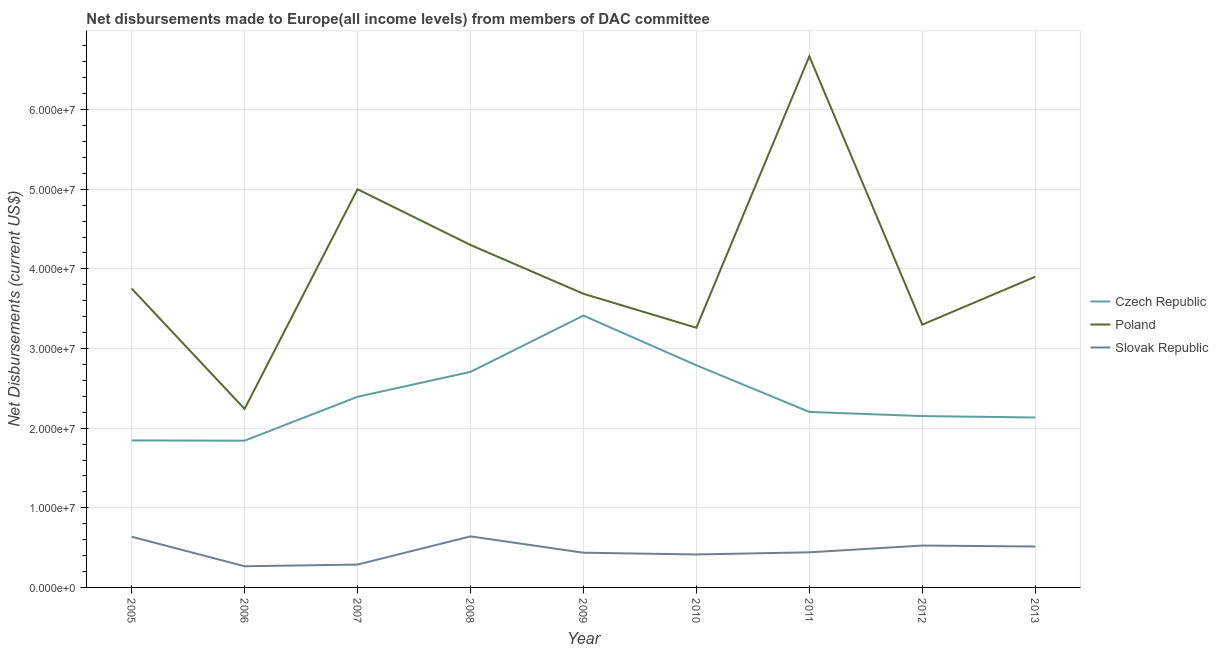How many different coloured lines are there?
Your answer should be compact. 3. What is the net disbursements made by czech republic in 2013?
Your answer should be compact. 2.13e+07. Across all years, what is the maximum net disbursements made by czech republic?
Your answer should be very brief. 3.41e+07. Across all years, what is the minimum net disbursements made by czech republic?
Offer a very short reply. 1.84e+07. In which year was the net disbursements made by poland maximum?
Make the answer very short. 2011. What is the total net disbursements made by poland in the graph?
Make the answer very short. 3.61e+08. What is the difference between the net disbursements made by poland in 2009 and that in 2012?
Provide a short and direct response. 3.88e+06. What is the difference between the net disbursements made by slovak republic in 2013 and the net disbursements made by czech republic in 2007?
Offer a terse response. -1.88e+07. What is the average net disbursements made by slovak republic per year?
Make the answer very short. 4.62e+06. In the year 2009, what is the difference between the net disbursements made by poland and net disbursements made by czech republic?
Ensure brevity in your answer.  2.74e+06. What is the ratio of the net disbursements made by czech republic in 2010 to that in 2012?
Make the answer very short. 1.3. What is the difference between the highest and the lowest net disbursements made by poland?
Offer a very short reply. 4.43e+07. In how many years, is the net disbursements made by czech republic greater than the average net disbursements made by czech republic taken over all years?
Make the answer very short. 4. Is the sum of the net disbursements made by poland in 2006 and 2009 greater than the maximum net disbursements made by czech republic across all years?
Give a very brief answer. Yes. Does the net disbursements made by poland monotonically increase over the years?
Ensure brevity in your answer.  No. Is the net disbursements made by czech republic strictly greater than the net disbursements made by poland over the years?
Provide a succinct answer. No. Is the net disbursements made by slovak republic strictly less than the net disbursements made by poland over the years?
Offer a terse response. Yes. How many lines are there?
Your response must be concise. 3. How many years are there in the graph?
Your answer should be very brief. 9. Does the graph contain any zero values?
Give a very brief answer. No. Where does the legend appear in the graph?
Offer a terse response. Center right. How many legend labels are there?
Your answer should be very brief. 3. How are the legend labels stacked?
Make the answer very short. Vertical. What is the title of the graph?
Your answer should be compact. Net disbursements made to Europe(all income levels) from members of DAC committee. Does "Taxes on income" appear as one of the legend labels in the graph?
Offer a very short reply. No. What is the label or title of the X-axis?
Provide a short and direct response. Year. What is the label or title of the Y-axis?
Keep it short and to the point. Net Disbursements (current US$). What is the Net Disbursements (current US$) of Czech Republic in 2005?
Your answer should be compact. 1.85e+07. What is the Net Disbursements (current US$) in Poland in 2005?
Your response must be concise. 3.75e+07. What is the Net Disbursements (current US$) in Slovak Republic in 2005?
Offer a very short reply. 6.37e+06. What is the Net Disbursements (current US$) in Czech Republic in 2006?
Offer a terse response. 1.84e+07. What is the Net Disbursements (current US$) of Poland in 2006?
Give a very brief answer. 2.24e+07. What is the Net Disbursements (current US$) of Slovak Republic in 2006?
Provide a succinct answer. 2.66e+06. What is the Net Disbursements (current US$) of Czech Republic in 2007?
Make the answer very short. 2.39e+07. What is the Net Disbursements (current US$) of Poland in 2007?
Provide a short and direct response. 5.00e+07. What is the Net Disbursements (current US$) in Slovak Republic in 2007?
Offer a terse response. 2.87e+06. What is the Net Disbursements (current US$) in Czech Republic in 2008?
Your response must be concise. 2.71e+07. What is the Net Disbursements (current US$) of Poland in 2008?
Your answer should be compact. 4.30e+07. What is the Net Disbursements (current US$) of Slovak Republic in 2008?
Offer a very short reply. 6.41e+06. What is the Net Disbursements (current US$) of Czech Republic in 2009?
Provide a succinct answer. 3.41e+07. What is the Net Disbursements (current US$) in Poland in 2009?
Offer a very short reply. 3.69e+07. What is the Net Disbursements (current US$) of Slovak Republic in 2009?
Offer a terse response. 4.36e+06. What is the Net Disbursements (current US$) in Czech Republic in 2010?
Give a very brief answer. 2.79e+07. What is the Net Disbursements (current US$) of Poland in 2010?
Your answer should be compact. 3.26e+07. What is the Net Disbursements (current US$) in Slovak Republic in 2010?
Your response must be concise. 4.14e+06. What is the Net Disbursements (current US$) in Czech Republic in 2011?
Your answer should be compact. 2.20e+07. What is the Net Disbursements (current US$) of Poland in 2011?
Offer a very short reply. 6.67e+07. What is the Net Disbursements (current US$) in Slovak Republic in 2011?
Make the answer very short. 4.41e+06. What is the Net Disbursements (current US$) of Czech Republic in 2012?
Offer a terse response. 2.15e+07. What is the Net Disbursements (current US$) of Poland in 2012?
Provide a short and direct response. 3.30e+07. What is the Net Disbursements (current US$) in Slovak Republic in 2012?
Give a very brief answer. 5.26e+06. What is the Net Disbursements (current US$) of Czech Republic in 2013?
Offer a very short reply. 2.13e+07. What is the Net Disbursements (current US$) in Poland in 2013?
Provide a succinct answer. 3.90e+07. What is the Net Disbursements (current US$) in Slovak Republic in 2013?
Your response must be concise. 5.14e+06. Across all years, what is the maximum Net Disbursements (current US$) of Czech Republic?
Offer a terse response. 3.41e+07. Across all years, what is the maximum Net Disbursements (current US$) of Poland?
Give a very brief answer. 6.67e+07. Across all years, what is the maximum Net Disbursements (current US$) in Slovak Republic?
Keep it short and to the point. 6.41e+06. Across all years, what is the minimum Net Disbursements (current US$) in Czech Republic?
Your response must be concise. 1.84e+07. Across all years, what is the minimum Net Disbursements (current US$) in Poland?
Your answer should be very brief. 2.24e+07. Across all years, what is the minimum Net Disbursements (current US$) of Slovak Republic?
Ensure brevity in your answer.  2.66e+06. What is the total Net Disbursements (current US$) in Czech Republic in the graph?
Your response must be concise. 2.15e+08. What is the total Net Disbursements (current US$) in Poland in the graph?
Ensure brevity in your answer.  3.61e+08. What is the total Net Disbursements (current US$) of Slovak Republic in the graph?
Your response must be concise. 4.16e+07. What is the difference between the Net Disbursements (current US$) of Poland in 2005 and that in 2006?
Provide a short and direct response. 1.51e+07. What is the difference between the Net Disbursements (current US$) of Slovak Republic in 2005 and that in 2006?
Ensure brevity in your answer.  3.71e+06. What is the difference between the Net Disbursements (current US$) in Czech Republic in 2005 and that in 2007?
Keep it short and to the point. -5.48e+06. What is the difference between the Net Disbursements (current US$) of Poland in 2005 and that in 2007?
Keep it short and to the point. -1.25e+07. What is the difference between the Net Disbursements (current US$) of Slovak Republic in 2005 and that in 2007?
Your answer should be compact. 3.50e+06. What is the difference between the Net Disbursements (current US$) of Czech Republic in 2005 and that in 2008?
Ensure brevity in your answer.  -8.61e+06. What is the difference between the Net Disbursements (current US$) of Poland in 2005 and that in 2008?
Your answer should be compact. -5.47e+06. What is the difference between the Net Disbursements (current US$) of Czech Republic in 2005 and that in 2009?
Provide a short and direct response. -1.57e+07. What is the difference between the Net Disbursements (current US$) in Slovak Republic in 2005 and that in 2009?
Provide a short and direct response. 2.01e+06. What is the difference between the Net Disbursements (current US$) in Czech Republic in 2005 and that in 2010?
Provide a short and direct response. -9.44e+06. What is the difference between the Net Disbursements (current US$) of Poland in 2005 and that in 2010?
Offer a terse response. 4.93e+06. What is the difference between the Net Disbursements (current US$) of Slovak Republic in 2005 and that in 2010?
Your answer should be compact. 2.23e+06. What is the difference between the Net Disbursements (current US$) in Czech Republic in 2005 and that in 2011?
Ensure brevity in your answer.  -3.58e+06. What is the difference between the Net Disbursements (current US$) in Poland in 2005 and that in 2011?
Keep it short and to the point. -2.92e+07. What is the difference between the Net Disbursements (current US$) in Slovak Republic in 2005 and that in 2011?
Ensure brevity in your answer.  1.96e+06. What is the difference between the Net Disbursements (current US$) in Czech Republic in 2005 and that in 2012?
Offer a terse response. -3.06e+06. What is the difference between the Net Disbursements (current US$) in Poland in 2005 and that in 2012?
Make the answer very short. 4.54e+06. What is the difference between the Net Disbursements (current US$) in Slovak Republic in 2005 and that in 2012?
Provide a short and direct response. 1.11e+06. What is the difference between the Net Disbursements (current US$) in Czech Republic in 2005 and that in 2013?
Make the answer very short. -2.88e+06. What is the difference between the Net Disbursements (current US$) of Poland in 2005 and that in 2013?
Provide a short and direct response. -1.48e+06. What is the difference between the Net Disbursements (current US$) in Slovak Republic in 2005 and that in 2013?
Provide a succinct answer. 1.23e+06. What is the difference between the Net Disbursements (current US$) of Czech Republic in 2006 and that in 2007?
Your answer should be very brief. -5.51e+06. What is the difference between the Net Disbursements (current US$) in Poland in 2006 and that in 2007?
Your answer should be compact. -2.76e+07. What is the difference between the Net Disbursements (current US$) in Czech Republic in 2006 and that in 2008?
Provide a succinct answer. -8.64e+06. What is the difference between the Net Disbursements (current US$) of Poland in 2006 and that in 2008?
Provide a succinct answer. -2.06e+07. What is the difference between the Net Disbursements (current US$) in Slovak Republic in 2006 and that in 2008?
Your response must be concise. -3.75e+06. What is the difference between the Net Disbursements (current US$) of Czech Republic in 2006 and that in 2009?
Your response must be concise. -1.57e+07. What is the difference between the Net Disbursements (current US$) in Poland in 2006 and that in 2009?
Provide a succinct answer. -1.45e+07. What is the difference between the Net Disbursements (current US$) in Slovak Republic in 2006 and that in 2009?
Give a very brief answer. -1.70e+06. What is the difference between the Net Disbursements (current US$) of Czech Republic in 2006 and that in 2010?
Give a very brief answer. -9.47e+06. What is the difference between the Net Disbursements (current US$) in Poland in 2006 and that in 2010?
Keep it short and to the point. -1.02e+07. What is the difference between the Net Disbursements (current US$) of Slovak Republic in 2006 and that in 2010?
Offer a terse response. -1.48e+06. What is the difference between the Net Disbursements (current US$) in Czech Republic in 2006 and that in 2011?
Give a very brief answer. -3.61e+06. What is the difference between the Net Disbursements (current US$) of Poland in 2006 and that in 2011?
Offer a very short reply. -4.43e+07. What is the difference between the Net Disbursements (current US$) of Slovak Republic in 2006 and that in 2011?
Offer a very short reply. -1.75e+06. What is the difference between the Net Disbursements (current US$) in Czech Republic in 2006 and that in 2012?
Offer a very short reply. -3.09e+06. What is the difference between the Net Disbursements (current US$) in Poland in 2006 and that in 2012?
Keep it short and to the point. -1.06e+07. What is the difference between the Net Disbursements (current US$) of Slovak Republic in 2006 and that in 2012?
Ensure brevity in your answer.  -2.60e+06. What is the difference between the Net Disbursements (current US$) in Czech Republic in 2006 and that in 2013?
Keep it short and to the point. -2.91e+06. What is the difference between the Net Disbursements (current US$) of Poland in 2006 and that in 2013?
Your answer should be compact. -1.66e+07. What is the difference between the Net Disbursements (current US$) in Slovak Republic in 2006 and that in 2013?
Keep it short and to the point. -2.48e+06. What is the difference between the Net Disbursements (current US$) in Czech Republic in 2007 and that in 2008?
Your answer should be compact. -3.13e+06. What is the difference between the Net Disbursements (current US$) of Poland in 2007 and that in 2008?
Your answer should be very brief. 7.00e+06. What is the difference between the Net Disbursements (current US$) in Slovak Republic in 2007 and that in 2008?
Make the answer very short. -3.54e+06. What is the difference between the Net Disbursements (current US$) of Czech Republic in 2007 and that in 2009?
Provide a short and direct response. -1.02e+07. What is the difference between the Net Disbursements (current US$) of Poland in 2007 and that in 2009?
Offer a terse response. 1.31e+07. What is the difference between the Net Disbursements (current US$) in Slovak Republic in 2007 and that in 2009?
Provide a succinct answer. -1.49e+06. What is the difference between the Net Disbursements (current US$) in Czech Republic in 2007 and that in 2010?
Offer a terse response. -3.96e+06. What is the difference between the Net Disbursements (current US$) in Poland in 2007 and that in 2010?
Ensure brevity in your answer.  1.74e+07. What is the difference between the Net Disbursements (current US$) in Slovak Republic in 2007 and that in 2010?
Provide a succinct answer. -1.27e+06. What is the difference between the Net Disbursements (current US$) in Czech Republic in 2007 and that in 2011?
Your answer should be very brief. 1.90e+06. What is the difference between the Net Disbursements (current US$) in Poland in 2007 and that in 2011?
Make the answer very short. -1.67e+07. What is the difference between the Net Disbursements (current US$) in Slovak Republic in 2007 and that in 2011?
Give a very brief answer. -1.54e+06. What is the difference between the Net Disbursements (current US$) of Czech Republic in 2007 and that in 2012?
Provide a succinct answer. 2.42e+06. What is the difference between the Net Disbursements (current US$) of Poland in 2007 and that in 2012?
Your response must be concise. 1.70e+07. What is the difference between the Net Disbursements (current US$) in Slovak Republic in 2007 and that in 2012?
Give a very brief answer. -2.39e+06. What is the difference between the Net Disbursements (current US$) of Czech Republic in 2007 and that in 2013?
Give a very brief answer. 2.60e+06. What is the difference between the Net Disbursements (current US$) in Poland in 2007 and that in 2013?
Provide a short and direct response. 1.10e+07. What is the difference between the Net Disbursements (current US$) of Slovak Republic in 2007 and that in 2013?
Provide a succinct answer. -2.27e+06. What is the difference between the Net Disbursements (current US$) of Czech Republic in 2008 and that in 2009?
Provide a short and direct response. -7.07e+06. What is the difference between the Net Disbursements (current US$) in Poland in 2008 and that in 2009?
Keep it short and to the point. 6.13e+06. What is the difference between the Net Disbursements (current US$) in Slovak Republic in 2008 and that in 2009?
Your answer should be compact. 2.05e+06. What is the difference between the Net Disbursements (current US$) of Czech Republic in 2008 and that in 2010?
Make the answer very short. -8.30e+05. What is the difference between the Net Disbursements (current US$) of Poland in 2008 and that in 2010?
Offer a terse response. 1.04e+07. What is the difference between the Net Disbursements (current US$) of Slovak Republic in 2008 and that in 2010?
Keep it short and to the point. 2.27e+06. What is the difference between the Net Disbursements (current US$) of Czech Republic in 2008 and that in 2011?
Offer a very short reply. 5.03e+06. What is the difference between the Net Disbursements (current US$) of Poland in 2008 and that in 2011?
Offer a terse response. -2.37e+07. What is the difference between the Net Disbursements (current US$) of Czech Republic in 2008 and that in 2012?
Provide a short and direct response. 5.55e+06. What is the difference between the Net Disbursements (current US$) in Poland in 2008 and that in 2012?
Your answer should be compact. 1.00e+07. What is the difference between the Net Disbursements (current US$) of Slovak Republic in 2008 and that in 2012?
Offer a very short reply. 1.15e+06. What is the difference between the Net Disbursements (current US$) of Czech Republic in 2008 and that in 2013?
Provide a succinct answer. 5.73e+06. What is the difference between the Net Disbursements (current US$) of Poland in 2008 and that in 2013?
Keep it short and to the point. 3.99e+06. What is the difference between the Net Disbursements (current US$) of Slovak Republic in 2008 and that in 2013?
Your answer should be very brief. 1.27e+06. What is the difference between the Net Disbursements (current US$) of Czech Republic in 2009 and that in 2010?
Give a very brief answer. 6.24e+06. What is the difference between the Net Disbursements (current US$) of Poland in 2009 and that in 2010?
Your response must be concise. 4.27e+06. What is the difference between the Net Disbursements (current US$) of Czech Republic in 2009 and that in 2011?
Offer a very short reply. 1.21e+07. What is the difference between the Net Disbursements (current US$) in Poland in 2009 and that in 2011?
Give a very brief answer. -2.98e+07. What is the difference between the Net Disbursements (current US$) in Slovak Republic in 2009 and that in 2011?
Ensure brevity in your answer.  -5.00e+04. What is the difference between the Net Disbursements (current US$) in Czech Republic in 2009 and that in 2012?
Your answer should be very brief. 1.26e+07. What is the difference between the Net Disbursements (current US$) of Poland in 2009 and that in 2012?
Offer a terse response. 3.88e+06. What is the difference between the Net Disbursements (current US$) in Slovak Republic in 2009 and that in 2012?
Offer a very short reply. -9.00e+05. What is the difference between the Net Disbursements (current US$) of Czech Republic in 2009 and that in 2013?
Provide a short and direct response. 1.28e+07. What is the difference between the Net Disbursements (current US$) of Poland in 2009 and that in 2013?
Give a very brief answer. -2.14e+06. What is the difference between the Net Disbursements (current US$) in Slovak Republic in 2009 and that in 2013?
Provide a short and direct response. -7.80e+05. What is the difference between the Net Disbursements (current US$) in Czech Republic in 2010 and that in 2011?
Offer a very short reply. 5.86e+06. What is the difference between the Net Disbursements (current US$) in Poland in 2010 and that in 2011?
Make the answer very short. -3.41e+07. What is the difference between the Net Disbursements (current US$) of Czech Republic in 2010 and that in 2012?
Provide a succinct answer. 6.38e+06. What is the difference between the Net Disbursements (current US$) in Poland in 2010 and that in 2012?
Give a very brief answer. -3.90e+05. What is the difference between the Net Disbursements (current US$) in Slovak Republic in 2010 and that in 2012?
Your response must be concise. -1.12e+06. What is the difference between the Net Disbursements (current US$) of Czech Republic in 2010 and that in 2013?
Offer a very short reply. 6.56e+06. What is the difference between the Net Disbursements (current US$) in Poland in 2010 and that in 2013?
Your response must be concise. -6.41e+06. What is the difference between the Net Disbursements (current US$) in Czech Republic in 2011 and that in 2012?
Ensure brevity in your answer.  5.20e+05. What is the difference between the Net Disbursements (current US$) of Poland in 2011 and that in 2012?
Make the answer very short. 3.37e+07. What is the difference between the Net Disbursements (current US$) of Slovak Republic in 2011 and that in 2012?
Offer a very short reply. -8.50e+05. What is the difference between the Net Disbursements (current US$) in Poland in 2011 and that in 2013?
Offer a terse response. 2.77e+07. What is the difference between the Net Disbursements (current US$) of Slovak Republic in 2011 and that in 2013?
Offer a terse response. -7.30e+05. What is the difference between the Net Disbursements (current US$) of Poland in 2012 and that in 2013?
Give a very brief answer. -6.02e+06. What is the difference between the Net Disbursements (current US$) in Slovak Republic in 2012 and that in 2013?
Offer a very short reply. 1.20e+05. What is the difference between the Net Disbursements (current US$) in Czech Republic in 2005 and the Net Disbursements (current US$) in Poland in 2006?
Make the answer very short. -3.96e+06. What is the difference between the Net Disbursements (current US$) in Czech Republic in 2005 and the Net Disbursements (current US$) in Slovak Republic in 2006?
Your answer should be very brief. 1.58e+07. What is the difference between the Net Disbursements (current US$) in Poland in 2005 and the Net Disbursements (current US$) in Slovak Republic in 2006?
Make the answer very short. 3.49e+07. What is the difference between the Net Disbursements (current US$) in Czech Republic in 2005 and the Net Disbursements (current US$) in Poland in 2007?
Provide a short and direct response. -3.16e+07. What is the difference between the Net Disbursements (current US$) of Czech Republic in 2005 and the Net Disbursements (current US$) of Slovak Republic in 2007?
Ensure brevity in your answer.  1.56e+07. What is the difference between the Net Disbursements (current US$) in Poland in 2005 and the Net Disbursements (current US$) in Slovak Republic in 2007?
Offer a terse response. 3.47e+07. What is the difference between the Net Disbursements (current US$) of Czech Republic in 2005 and the Net Disbursements (current US$) of Poland in 2008?
Your answer should be compact. -2.46e+07. What is the difference between the Net Disbursements (current US$) in Czech Republic in 2005 and the Net Disbursements (current US$) in Slovak Republic in 2008?
Your answer should be compact. 1.20e+07. What is the difference between the Net Disbursements (current US$) of Poland in 2005 and the Net Disbursements (current US$) of Slovak Republic in 2008?
Give a very brief answer. 3.11e+07. What is the difference between the Net Disbursements (current US$) of Czech Republic in 2005 and the Net Disbursements (current US$) of Poland in 2009?
Give a very brief answer. -1.84e+07. What is the difference between the Net Disbursements (current US$) of Czech Republic in 2005 and the Net Disbursements (current US$) of Slovak Republic in 2009?
Your answer should be compact. 1.41e+07. What is the difference between the Net Disbursements (current US$) in Poland in 2005 and the Net Disbursements (current US$) in Slovak Republic in 2009?
Provide a succinct answer. 3.32e+07. What is the difference between the Net Disbursements (current US$) in Czech Republic in 2005 and the Net Disbursements (current US$) in Poland in 2010?
Provide a short and direct response. -1.42e+07. What is the difference between the Net Disbursements (current US$) of Czech Republic in 2005 and the Net Disbursements (current US$) of Slovak Republic in 2010?
Your response must be concise. 1.43e+07. What is the difference between the Net Disbursements (current US$) of Poland in 2005 and the Net Disbursements (current US$) of Slovak Republic in 2010?
Ensure brevity in your answer.  3.34e+07. What is the difference between the Net Disbursements (current US$) of Czech Republic in 2005 and the Net Disbursements (current US$) of Poland in 2011?
Keep it short and to the point. -4.82e+07. What is the difference between the Net Disbursements (current US$) of Czech Republic in 2005 and the Net Disbursements (current US$) of Slovak Republic in 2011?
Offer a terse response. 1.40e+07. What is the difference between the Net Disbursements (current US$) in Poland in 2005 and the Net Disbursements (current US$) in Slovak Republic in 2011?
Provide a short and direct response. 3.31e+07. What is the difference between the Net Disbursements (current US$) in Czech Republic in 2005 and the Net Disbursements (current US$) in Poland in 2012?
Ensure brevity in your answer.  -1.45e+07. What is the difference between the Net Disbursements (current US$) of Czech Republic in 2005 and the Net Disbursements (current US$) of Slovak Republic in 2012?
Provide a succinct answer. 1.32e+07. What is the difference between the Net Disbursements (current US$) of Poland in 2005 and the Net Disbursements (current US$) of Slovak Republic in 2012?
Ensure brevity in your answer.  3.23e+07. What is the difference between the Net Disbursements (current US$) in Czech Republic in 2005 and the Net Disbursements (current US$) in Poland in 2013?
Keep it short and to the point. -2.06e+07. What is the difference between the Net Disbursements (current US$) in Czech Republic in 2005 and the Net Disbursements (current US$) in Slovak Republic in 2013?
Provide a succinct answer. 1.33e+07. What is the difference between the Net Disbursements (current US$) of Poland in 2005 and the Net Disbursements (current US$) of Slovak Republic in 2013?
Offer a terse response. 3.24e+07. What is the difference between the Net Disbursements (current US$) of Czech Republic in 2006 and the Net Disbursements (current US$) of Poland in 2007?
Provide a short and direct response. -3.16e+07. What is the difference between the Net Disbursements (current US$) of Czech Republic in 2006 and the Net Disbursements (current US$) of Slovak Republic in 2007?
Keep it short and to the point. 1.56e+07. What is the difference between the Net Disbursements (current US$) in Poland in 2006 and the Net Disbursements (current US$) in Slovak Republic in 2007?
Your response must be concise. 1.96e+07. What is the difference between the Net Disbursements (current US$) of Czech Republic in 2006 and the Net Disbursements (current US$) of Poland in 2008?
Keep it short and to the point. -2.46e+07. What is the difference between the Net Disbursements (current US$) in Czech Republic in 2006 and the Net Disbursements (current US$) in Slovak Republic in 2008?
Ensure brevity in your answer.  1.20e+07. What is the difference between the Net Disbursements (current US$) in Poland in 2006 and the Net Disbursements (current US$) in Slovak Republic in 2008?
Make the answer very short. 1.60e+07. What is the difference between the Net Disbursements (current US$) in Czech Republic in 2006 and the Net Disbursements (current US$) in Poland in 2009?
Offer a very short reply. -1.84e+07. What is the difference between the Net Disbursements (current US$) of Czech Republic in 2006 and the Net Disbursements (current US$) of Slovak Republic in 2009?
Provide a short and direct response. 1.41e+07. What is the difference between the Net Disbursements (current US$) in Poland in 2006 and the Net Disbursements (current US$) in Slovak Republic in 2009?
Give a very brief answer. 1.81e+07. What is the difference between the Net Disbursements (current US$) in Czech Republic in 2006 and the Net Disbursements (current US$) in Poland in 2010?
Ensure brevity in your answer.  -1.42e+07. What is the difference between the Net Disbursements (current US$) of Czech Republic in 2006 and the Net Disbursements (current US$) of Slovak Republic in 2010?
Offer a terse response. 1.43e+07. What is the difference between the Net Disbursements (current US$) of Poland in 2006 and the Net Disbursements (current US$) of Slovak Republic in 2010?
Provide a short and direct response. 1.83e+07. What is the difference between the Net Disbursements (current US$) of Czech Republic in 2006 and the Net Disbursements (current US$) of Poland in 2011?
Make the answer very short. -4.83e+07. What is the difference between the Net Disbursements (current US$) of Czech Republic in 2006 and the Net Disbursements (current US$) of Slovak Republic in 2011?
Offer a very short reply. 1.40e+07. What is the difference between the Net Disbursements (current US$) in Poland in 2006 and the Net Disbursements (current US$) in Slovak Republic in 2011?
Ensure brevity in your answer.  1.80e+07. What is the difference between the Net Disbursements (current US$) of Czech Republic in 2006 and the Net Disbursements (current US$) of Poland in 2012?
Your answer should be compact. -1.46e+07. What is the difference between the Net Disbursements (current US$) of Czech Republic in 2006 and the Net Disbursements (current US$) of Slovak Republic in 2012?
Ensure brevity in your answer.  1.32e+07. What is the difference between the Net Disbursements (current US$) of Poland in 2006 and the Net Disbursements (current US$) of Slovak Republic in 2012?
Make the answer very short. 1.72e+07. What is the difference between the Net Disbursements (current US$) in Czech Republic in 2006 and the Net Disbursements (current US$) in Poland in 2013?
Give a very brief answer. -2.06e+07. What is the difference between the Net Disbursements (current US$) in Czech Republic in 2006 and the Net Disbursements (current US$) in Slovak Republic in 2013?
Ensure brevity in your answer.  1.33e+07. What is the difference between the Net Disbursements (current US$) of Poland in 2006 and the Net Disbursements (current US$) of Slovak Republic in 2013?
Provide a succinct answer. 1.73e+07. What is the difference between the Net Disbursements (current US$) of Czech Republic in 2007 and the Net Disbursements (current US$) of Poland in 2008?
Provide a short and direct response. -1.91e+07. What is the difference between the Net Disbursements (current US$) of Czech Republic in 2007 and the Net Disbursements (current US$) of Slovak Republic in 2008?
Keep it short and to the point. 1.75e+07. What is the difference between the Net Disbursements (current US$) of Poland in 2007 and the Net Disbursements (current US$) of Slovak Republic in 2008?
Your response must be concise. 4.36e+07. What is the difference between the Net Disbursements (current US$) in Czech Republic in 2007 and the Net Disbursements (current US$) in Poland in 2009?
Give a very brief answer. -1.29e+07. What is the difference between the Net Disbursements (current US$) of Czech Republic in 2007 and the Net Disbursements (current US$) of Slovak Republic in 2009?
Provide a short and direct response. 1.96e+07. What is the difference between the Net Disbursements (current US$) of Poland in 2007 and the Net Disbursements (current US$) of Slovak Republic in 2009?
Provide a succinct answer. 4.56e+07. What is the difference between the Net Disbursements (current US$) of Czech Republic in 2007 and the Net Disbursements (current US$) of Poland in 2010?
Provide a succinct answer. -8.67e+06. What is the difference between the Net Disbursements (current US$) in Czech Republic in 2007 and the Net Disbursements (current US$) in Slovak Republic in 2010?
Provide a succinct answer. 1.98e+07. What is the difference between the Net Disbursements (current US$) of Poland in 2007 and the Net Disbursements (current US$) of Slovak Republic in 2010?
Your answer should be compact. 4.59e+07. What is the difference between the Net Disbursements (current US$) of Czech Republic in 2007 and the Net Disbursements (current US$) of Poland in 2011?
Make the answer very short. -4.28e+07. What is the difference between the Net Disbursements (current US$) of Czech Republic in 2007 and the Net Disbursements (current US$) of Slovak Republic in 2011?
Provide a short and direct response. 1.95e+07. What is the difference between the Net Disbursements (current US$) in Poland in 2007 and the Net Disbursements (current US$) in Slovak Republic in 2011?
Offer a terse response. 4.56e+07. What is the difference between the Net Disbursements (current US$) of Czech Republic in 2007 and the Net Disbursements (current US$) of Poland in 2012?
Offer a very short reply. -9.06e+06. What is the difference between the Net Disbursements (current US$) in Czech Republic in 2007 and the Net Disbursements (current US$) in Slovak Republic in 2012?
Offer a very short reply. 1.87e+07. What is the difference between the Net Disbursements (current US$) in Poland in 2007 and the Net Disbursements (current US$) in Slovak Republic in 2012?
Offer a terse response. 4.48e+07. What is the difference between the Net Disbursements (current US$) of Czech Republic in 2007 and the Net Disbursements (current US$) of Poland in 2013?
Ensure brevity in your answer.  -1.51e+07. What is the difference between the Net Disbursements (current US$) in Czech Republic in 2007 and the Net Disbursements (current US$) in Slovak Republic in 2013?
Give a very brief answer. 1.88e+07. What is the difference between the Net Disbursements (current US$) of Poland in 2007 and the Net Disbursements (current US$) of Slovak Republic in 2013?
Provide a succinct answer. 4.49e+07. What is the difference between the Net Disbursements (current US$) in Czech Republic in 2008 and the Net Disbursements (current US$) in Poland in 2009?
Offer a terse response. -9.81e+06. What is the difference between the Net Disbursements (current US$) of Czech Republic in 2008 and the Net Disbursements (current US$) of Slovak Republic in 2009?
Make the answer very short. 2.27e+07. What is the difference between the Net Disbursements (current US$) in Poland in 2008 and the Net Disbursements (current US$) in Slovak Republic in 2009?
Your response must be concise. 3.86e+07. What is the difference between the Net Disbursements (current US$) in Czech Republic in 2008 and the Net Disbursements (current US$) in Poland in 2010?
Offer a terse response. -5.54e+06. What is the difference between the Net Disbursements (current US$) of Czech Republic in 2008 and the Net Disbursements (current US$) of Slovak Republic in 2010?
Give a very brief answer. 2.29e+07. What is the difference between the Net Disbursements (current US$) in Poland in 2008 and the Net Disbursements (current US$) in Slovak Republic in 2010?
Give a very brief answer. 3.89e+07. What is the difference between the Net Disbursements (current US$) of Czech Republic in 2008 and the Net Disbursements (current US$) of Poland in 2011?
Offer a very short reply. -3.96e+07. What is the difference between the Net Disbursements (current US$) of Czech Republic in 2008 and the Net Disbursements (current US$) of Slovak Republic in 2011?
Your answer should be very brief. 2.27e+07. What is the difference between the Net Disbursements (current US$) in Poland in 2008 and the Net Disbursements (current US$) in Slovak Republic in 2011?
Keep it short and to the point. 3.86e+07. What is the difference between the Net Disbursements (current US$) in Czech Republic in 2008 and the Net Disbursements (current US$) in Poland in 2012?
Keep it short and to the point. -5.93e+06. What is the difference between the Net Disbursements (current US$) of Czech Republic in 2008 and the Net Disbursements (current US$) of Slovak Republic in 2012?
Offer a terse response. 2.18e+07. What is the difference between the Net Disbursements (current US$) of Poland in 2008 and the Net Disbursements (current US$) of Slovak Republic in 2012?
Provide a succinct answer. 3.78e+07. What is the difference between the Net Disbursements (current US$) in Czech Republic in 2008 and the Net Disbursements (current US$) in Poland in 2013?
Your answer should be very brief. -1.20e+07. What is the difference between the Net Disbursements (current US$) of Czech Republic in 2008 and the Net Disbursements (current US$) of Slovak Republic in 2013?
Your answer should be compact. 2.19e+07. What is the difference between the Net Disbursements (current US$) of Poland in 2008 and the Net Disbursements (current US$) of Slovak Republic in 2013?
Offer a terse response. 3.79e+07. What is the difference between the Net Disbursements (current US$) in Czech Republic in 2009 and the Net Disbursements (current US$) in Poland in 2010?
Provide a succinct answer. 1.53e+06. What is the difference between the Net Disbursements (current US$) of Czech Republic in 2009 and the Net Disbursements (current US$) of Slovak Republic in 2010?
Provide a succinct answer. 3.00e+07. What is the difference between the Net Disbursements (current US$) of Poland in 2009 and the Net Disbursements (current US$) of Slovak Republic in 2010?
Your answer should be very brief. 3.27e+07. What is the difference between the Net Disbursements (current US$) of Czech Republic in 2009 and the Net Disbursements (current US$) of Poland in 2011?
Provide a succinct answer. -3.26e+07. What is the difference between the Net Disbursements (current US$) of Czech Republic in 2009 and the Net Disbursements (current US$) of Slovak Republic in 2011?
Offer a very short reply. 2.97e+07. What is the difference between the Net Disbursements (current US$) in Poland in 2009 and the Net Disbursements (current US$) in Slovak Republic in 2011?
Give a very brief answer. 3.25e+07. What is the difference between the Net Disbursements (current US$) of Czech Republic in 2009 and the Net Disbursements (current US$) of Poland in 2012?
Your response must be concise. 1.14e+06. What is the difference between the Net Disbursements (current US$) of Czech Republic in 2009 and the Net Disbursements (current US$) of Slovak Republic in 2012?
Provide a short and direct response. 2.89e+07. What is the difference between the Net Disbursements (current US$) in Poland in 2009 and the Net Disbursements (current US$) in Slovak Republic in 2012?
Provide a succinct answer. 3.16e+07. What is the difference between the Net Disbursements (current US$) of Czech Republic in 2009 and the Net Disbursements (current US$) of Poland in 2013?
Make the answer very short. -4.88e+06. What is the difference between the Net Disbursements (current US$) of Czech Republic in 2009 and the Net Disbursements (current US$) of Slovak Republic in 2013?
Your answer should be compact. 2.90e+07. What is the difference between the Net Disbursements (current US$) of Poland in 2009 and the Net Disbursements (current US$) of Slovak Republic in 2013?
Keep it short and to the point. 3.17e+07. What is the difference between the Net Disbursements (current US$) in Czech Republic in 2010 and the Net Disbursements (current US$) in Poland in 2011?
Your response must be concise. -3.88e+07. What is the difference between the Net Disbursements (current US$) in Czech Republic in 2010 and the Net Disbursements (current US$) in Slovak Republic in 2011?
Your answer should be very brief. 2.35e+07. What is the difference between the Net Disbursements (current US$) of Poland in 2010 and the Net Disbursements (current US$) of Slovak Republic in 2011?
Make the answer very short. 2.82e+07. What is the difference between the Net Disbursements (current US$) of Czech Republic in 2010 and the Net Disbursements (current US$) of Poland in 2012?
Your answer should be very brief. -5.10e+06. What is the difference between the Net Disbursements (current US$) in Czech Republic in 2010 and the Net Disbursements (current US$) in Slovak Republic in 2012?
Offer a very short reply. 2.26e+07. What is the difference between the Net Disbursements (current US$) of Poland in 2010 and the Net Disbursements (current US$) of Slovak Republic in 2012?
Your answer should be compact. 2.74e+07. What is the difference between the Net Disbursements (current US$) in Czech Republic in 2010 and the Net Disbursements (current US$) in Poland in 2013?
Give a very brief answer. -1.11e+07. What is the difference between the Net Disbursements (current US$) in Czech Republic in 2010 and the Net Disbursements (current US$) in Slovak Republic in 2013?
Your answer should be compact. 2.28e+07. What is the difference between the Net Disbursements (current US$) in Poland in 2010 and the Net Disbursements (current US$) in Slovak Republic in 2013?
Your answer should be very brief. 2.75e+07. What is the difference between the Net Disbursements (current US$) in Czech Republic in 2011 and the Net Disbursements (current US$) in Poland in 2012?
Offer a very short reply. -1.10e+07. What is the difference between the Net Disbursements (current US$) in Czech Republic in 2011 and the Net Disbursements (current US$) in Slovak Republic in 2012?
Provide a succinct answer. 1.68e+07. What is the difference between the Net Disbursements (current US$) in Poland in 2011 and the Net Disbursements (current US$) in Slovak Republic in 2012?
Give a very brief answer. 6.14e+07. What is the difference between the Net Disbursements (current US$) of Czech Republic in 2011 and the Net Disbursements (current US$) of Poland in 2013?
Give a very brief answer. -1.70e+07. What is the difference between the Net Disbursements (current US$) of Czech Republic in 2011 and the Net Disbursements (current US$) of Slovak Republic in 2013?
Give a very brief answer. 1.69e+07. What is the difference between the Net Disbursements (current US$) of Poland in 2011 and the Net Disbursements (current US$) of Slovak Republic in 2013?
Your answer should be compact. 6.16e+07. What is the difference between the Net Disbursements (current US$) in Czech Republic in 2012 and the Net Disbursements (current US$) in Poland in 2013?
Give a very brief answer. -1.75e+07. What is the difference between the Net Disbursements (current US$) of Czech Republic in 2012 and the Net Disbursements (current US$) of Slovak Republic in 2013?
Make the answer very short. 1.64e+07. What is the difference between the Net Disbursements (current US$) in Poland in 2012 and the Net Disbursements (current US$) in Slovak Republic in 2013?
Make the answer very short. 2.79e+07. What is the average Net Disbursements (current US$) of Czech Republic per year?
Give a very brief answer. 2.39e+07. What is the average Net Disbursements (current US$) of Poland per year?
Provide a succinct answer. 4.01e+07. What is the average Net Disbursements (current US$) in Slovak Republic per year?
Provide a succinct answer. 4.62e+06. In the year 2005, what is the difference between the Net Disbursements (current US$) in Czech Republic and Net Disbursements (current US$) in Poland?
Provide a short and direct response. -1.91e+07. In the year 2005, what is the difference between the Net Disbursements (current US$) of Czech Republic and Net Disbursements (current US$) of Slovak Republic?
Your answer should be very brief. 1.21e+07. In the year 2005, what is the difference between the Net Disbursements (current US$) of Poland and Net Disbursements (current US$) of Slovak Republic?
Give a very brief answer. 3.12e+07. In the year 2006, what is the difference between the Net Disbursements (current US$) in Czech Republic and Net Disbursements (current US$) in Poland?
Your response must be concise. -3.99e+06. In the year 2006, what is the difference between the Net Disbursements (current US$) in Czech Republic and Net Disbursements (current US$) in Slovak Republic?
Keep it short and to the point. 1.58e+07. In the year 2006, what is the difference between the Net Disbursements (current US$) of Poland and Net Disbursements (current US$) of Slovak Republic?
Offer a terse response. 1.98e+07. In the year 2007, what is the difference between the Net Disbursements (current US$) of Czech Republic and Net Disbursements (current US$) of Poland?
Make the answer very short. -2.61e+07. In the year 2007, what is the difference between the Net Disbursements (current US$) of Czech Republic and Net Disbursements (current US$) of Slovak Republic?
Ensure brevity in your answer.  2.11e+07. In the year 2007, what is the difference between the Net Disbursements (current US$) in Poland and Net Disbursements (current US$) in Slovak Republic?
Provide a succinct answer. 4.71e+07. In the year 2008, what is the difference between the Net Disbursements (current US$) in Czech Republic and Net Disbursements (current US$) in Poland?
Provide a succinct answer. -1.59e+07. In the year 2008, what is the difference between the Net Disbursements (current US$) in Czech Republic and Net Disbursements (current US$) in Slovak Republic?
Ensure brevity in your answer.  2.07e+07. In the year 2008, what is the difference between the Net Disbursements (current US$) in Poland and Net Disbursements (current US$) in Slovak Republic?
Offer a very short reply. 3.66e+07. In the year 2009, what is the difference between the Net Disbursements (current US$) in Czech Republic and Net Disbursements (current US$) in Poland?
Offer a terse response. -2.74e+06. In the year 2009, what is the difference between the Net Disbursements (current US$) in Czech Republic and Net Disbursements (current US$) in Slovak Republic?
Make the answer very short. 2.98e+07. In the year 2009, what is the difference between the Net Disbursements (current US$) of Poland and Net Disbursements (current US$) of Slovak Republic?
Provide a succinct answer. 3.25e+07. In the year 2010, what is the difference between the Net Disbursements (current US$) in Czech Republic and Net Disbursements (current US$) in Poland?
Your answer should be very brief. -4.71e+06. In the year 2010, what is the difference between the Net Disbursements (current US$) of Czech Republic and Net Disbursements (current US$) of Slovak Republic?
Offer a terse response. 2.38e+07. In the year 2010, what is the difference between the Net Disbursements (current US$) of Poland and Net Disbursements (current US$) of Slovak Republic?
Provide a succinct answer. 2.85e+07. In the year 2011, what is the difference between the Net Disbursements (current US$) in Czech Republic and Net Disbursements (current US$) in Poland?
Keep it short and to the point. -4.47e+07. In the year 2011, what is the difference between the Net Disbursements (current US$) in Czech Republic and Net Disbursements (current US$) in Slovak Republic?
Your response must be concise. 1.76e+07. In the year 2011, what is the difference between the Net Disbursements (current US$) of Poland and Net Disbursements (current US$) of Slovak Republic?
Provide a succinct answer. 6.23e+07. In the year 2012, what is the difference between the Net Disbursements (current US$) in Czech Republic and Net Disbursements (current US$) in Poland?
Provide a short and direct response. -1.15e+07. In the year 2012, what is the difference between the Net Disbursements (current US$) of Czech Republic and Net Disbursements (current US$) of Slovak Republic?
Give a very brief answer. 1.63e+07. In the year 2012, what is the difference between the Net Disbursements (current US$) of Poland and Net Disbursements (current US$) of Slovak Republic?
Offer a very short reply. 2.77e+07. In the year 2013, what is the difference between the Net Disbursements (current US$) in Czech Republic and Net Disbursements (current US$) in Poland?
Your answer should be very brief. -1.77e+07. In the year 2013, what is the difference between the Net Disbursements (current US$) of Czech Republic and Net Disbursements (current US$) of Slovak Republic?
Give a very brief answer. 1.62e+07. In the year 2013, what is the difference between the Net Disbursements (current US$) in Poland and Net Disbursements (current US$) in Slovak Republic?
Provide a short and direct response. 3.39e+07. What is the ratio of the Net Disbursements (current US$) in Poland in 2005 to that in 2006?
Make the answer very short. 1.67. What is the ratio of the Net Disbursements (current US$) in Slovak Republic in 2005 to that in 2006?
Give a very brief answer. 2.39. What is the ratio of the Net Disbursements (current US$) of Czech Republic in 2005 to that in 2007?
Your answer should be very brief. 0.77. What is the ratio of the Net Disbursements (current US$) of Poland in 2005 to that in 2007?
Offer a terse response. 0.75. What is the ratio of the Net Disbursements (current US$) of Slovak Republic in 2005 to that in 2007?
Your answer should be compact. 2.22. What is the ratio of the Net Disbursements (current US$) of Czech Republic in 2005 to that in 2008?
Provide a short and direct response. 0.68. What is the ratio of the Net Disbursements (current US$) in Poland in 2005 to that in 2008?
Provide a succinct answer. 0.87. What is the ratio of the Net Disbursements (current US$) of Czech Republic in 2005 to that in 2009?
Provide a succinct answer. 0.54. What is the ratio of the Net Disbursements (current US$) of Poland in 2005 to that in 2009?
Keep it short and to the point. 1.02. What is the ratio of the Net Disbursements (current US$) of Slovak Republic in 2005 to that in 2009?
Offer a terse response. 1.46. What is the ratio of the Net Disbursements (current US$) in Czech Republic in 2005 to that in 2010?
Give a very brief answer. 0.66. What is the ratio of the Net Disbursements (current US$) in Poland in 2005 to that in 2010?
Your response must be concise. 1.15. What is the ratio of the Net Disbursements (current US$) of Slovak Republic in 2005 to that in 2010?
Your response must be concise. 1.54. What is the ratio of the Net Disbursements (current US$) in Czech Republic in 2005 to that in 2011?
Offer a very short reply. 0.84. What is the ratio of the Net Disbursements (current US$) of Poland in 2005 to that in 2011?
Give a very brief answer. 0.56. What is the ratio of the Net Disbursements (current US$) of Slovak Republic in 2005 to that in 2011?
Give a very brief answer. 1.44. What is the ratio of the Net Disbursements (current US$) in Czech Republic in 2005 to that in 2012?
Provide a succinct answer. 0.86. What is the ratio of the Net Disbursements (current US$) in Poland in 2005 to that in 2012?
Ensure brevity in your answer.  1.14. What is the ratio of the Net Disbursements (current US$) in Slovak Republic in 2005 to that in 2012?
Give a very brief answer. 1.21. What is the ratio of the Net Disbursements (current US$) of Czech Republic in 2005 to that in 2013?
Your answer should be very brief. 0.86. What is the ratio of the Net Disbursements (current US$) of Poland in 2005 to that in 2013?
Ensure brevity in your answer.  0.96. What is the ratio of the Net Disbursements (current US$) of Slovak Republic in 2005 to that in 2013?
Give a very brief answer. 1.24. What is the ratio of the Net Disbursements (current US$) of Czech Republic in 2006 to that in 2007?
Your answer should be very brief. 0.77. What is the ratio of the Net Disbursements (current US$) in Poland in 2006 to that in 2007?
Offer a terse response. 0.45. What is the ratio of the Net Disbursements (current US$) in Slovak Republic in 2006 to that in 2007?
Provide a short and direct response. 0.93. What is the ratio of the Net Disbursements (current US$) of Czech Republic in 2006 to that in 2008?
Make the answer very short. 0.68. What is the ratio of the Net Disbursements (current US$) of Poland in 2006 to that in 2008?
Provide a succinct answer. 0.52. What is the ratio of the Net Disbursements (current US$) of Slovak Republic in 2006 to that in 2008?
Offer a very short reply. 0.41. What is the ratio of the Net Disbursements (current US$) in Czech Republic in 2006 to that in 2009?
Give a very brief answer. 0.54. What is the ratio of the Net Disbursements (current US$) in Poland in 2006 to that in 2009?
Ensure brevity in your answer.  0.61. What is the ratio of the Net Disbursements (current US$) of Slovak Republic in 2006 to that in 2009?
Provide a short and direct response. 0.61. What is the ratio of the Net Disbursements (current US$) of Czech Republic in 2006 to that in 2010?
Your response must be concise. 0.66. What is the ratio of the Net Disbursements (current US$) in Poland in 2006 to that in 2010?
Offer a very short reply. 0.69. What is the ratio of the Net Disbursements (current US$) of Slovak Republic in 2006 to that in 2010?
Give a very brief answer. 0.64. What is the ratio of the Net Disbursements (current US$) in Czech Republic in 2006 to that in 2011?
Keep it short and to the point. 0.84. What is the ratio of the Net Disbursements (current US$) of Poland in 2006 to that in 2011?
Keep it short and to the point. 0.34. What is the ratio of the Net Disbursements (current US$) of Slovak Republic in 2006 to that in 2011?
Make the answer very short. 0.6. What is the ratio of the Net Disbursements (current US$) in Czech Republic in 2006 to that in 2012?
Make the answer very short. 0.86. What is the ratio of the Net Disbursements (current US$) in Poland in 2006 to that in 2012?
Make the answer very short. 0.68. What is the ratio of the Net Disbursements (current US$) in Slovak Republic in 2006 to that in 2012?
Your response must be concise. 0.51. What is the ratio of the Net Disbursements (current US$) of Czech Republic in 2006 to that in 2013?
Provide a succinct answer. 0.86. What is the ratio of the Net Disbursements (current US$) of Poland in 2006 to that in 2013?
Offer a very short reply. 0.57. What is the ratio of the Net Disbursements (current US$) of Slovak Republic in 2006 to that in 2013?
Your answer should be very brief. 0.52. What is the ratio of the Net Disbursements (current US$) of Czech Republic in 2007 to that in 2008?
Give a very brief answer. 0.88. What is the ratio of the Net Disbursements (current US$) in Poland in 2007 to that in 2008?
Your answer should be compact. 1.16. What is the ratio of the Net Disbursements (current US$) of Slovak Republic in 2007 to that in 2008?
Provide a succinct answer. 0.45. What is the ratio of the Net Disbursements (current US$) of Czech Republic in 2007 to that in 2009?
Your answer should be compact. 0.7. What is the ratio of the Net Disbursements (current US$) in Poland in 2007 to that in 2009?
Make the answer very short. 1.36. What is the ratio of the Net Disbursements (current US$) in Slovak Republic in 2007 to that in 2009?
Keep it short and to the point. 0.66. What is the ratio of the Net Disbursements (current US$) of Czech Republic in 2007 to that in 2010?
Give a very brief answer. 0.86. What is the ratio of the Net Disbursements (current US$) of Poland in 2007 to that in 2010?
Offer a very short reply. 1.53. What is the ratio of the Net Disbursements (current US$) of Slovak Republic in 2007 to that in 2010?
Ensure brevity in your answer.  0.69. What is the ratio of the Net Disbursements (current US$) in Czech Republic in 2007 to that in 2011?
Provide a succinct answer. 1.09. What is the ratio of the Net Disbursements (current US$) of Poland in 2007 to that in 2011?
Keep it short and to the point. 0.75. What is the ratio of the Net Disbursements (current US$) in Slovak Republic in 2007 to that in 2011?
Your answer should be very brief. 0.65. What is the ratio of the Net Disbursements (current US$) in Czech Republic in 2007 to that in 2012?
Ensure brevity in your answer.  1.11. What is the ratio of the Net Disbursements (current US$) in Poland in 2007 to that in 2012?
Offer a terse response. 1.52. What is the ratio of the Net Disbursements (current US$) in Slovak Republic in 2007 to that in 2012?
Provide a succinct answer. 0.55. What is the ratio of the Net Disbursements (current US$) of Czech Republic in 2007 to that in 2013?
Provide a short and direct response. 1.12. What is the ratio of the Net Disbursements (current US$) in Poland in 2007 to that in 2013?
Offer a very short reply. 1.28. What is the ratio of the Net Disbursements (current US$) of Slovak Republic in 2007 to that in 2013?
Provide a succinct answer. 0.56. What is the ratio of the Net Disbursements (current US$) in Czech Republic in 2008 to that in 2009?
Your answer should be very brief. 0.79. What is the ratio of the Net Disbursements (current US$) in Poland in 2008 to that in 2009?
Ensure brevity in your answer.  1.17. What is the ratio of the Net Disbursements (current US$) of Slovak Republic in 2008 to that in 2009?
Your response must be concise. 1.47. What is the ratio of the Net Disbursements (current US$) of Czech Republic in 2008 to that in 2010?
Offer a terse response. 0.97. What is the ratio of the Net Disbursements (current US$) of Poland in 2008 to that in 2010?
Your answer should be compact. 1.32. What is the ratio of the Net Disbursements (current US$) of Slovak Republic in 2008 to that in 2010?
Ensure brevity in your answer.  1.55. What is the ratio of the Net Disbursements (current US$) of Czech Republic in 2008 to that in 2011?
Provide a succinct answer. 1.23. What is the ratio of the Net Disbursements (current US$) in Poland in 2008 to that in 2011?
Offer a very short reply. 0.64. What is the ratio of the Net Disbursements (current US$) in Slovak Republic in 2008 to that in 2011?
Give a very brief answer. 1.45. What is the ratio of the Net Disbursements (current US$) of Czech Republic in 2008 to that in 2012?
Offer a terse response. 1.26. What is the ratio of the Net Disbursements (current US$) of Poland in 2008 to that in 2012?
Your answer should be very brief. 1.3. What is the ratio of the Net Disbursements (current US$) in Slovak Republic in 2008 to that in 2012?
Provide a short and direct response. 1.22. What is the ratio of the Net Disbursements (current US$) in Czech Republic in 2008 to that in 2013?
Your answer should be compact. 1.27. What is the ratio of the Net Disbursements (current US$) of Poland in 2008 to that in 2013?
Ensure brevity in your answer.  1.1. What is the ratio of the Net Disbursements (current US$) in Slovak Republic in 2008 to that in 2013?
Your answer should be compact. 1.25. What is the ratio of the Net Disbursements (current US$) of Czech Republic in 2009 to that in 2010?
Your answer should be compact. 1.22. What is the ratio of the Net Disbursements (current US$) of Poland in 2009 to that in 2010?
Make the answer very short. 1.13. What is the ratio of the Net Disbursements (current US$) in Slovak Republic in 2009 to that in 2010?
Your answer should be compact. 1.05. What is the ratio of the Net Disbursements (current US$) in Czech Republic in 2009 to that in 2011?
Your answer should be compact. 1.55. What is the ratio of the Net Disbursements (current US$) of Poland in 2009 to that in 2011?
Make the answer very short. 0.55. What is the ratio of the Net Disbursements (current US$) in Slovak Republic in 2009 to that in 2011?
Your answer should be compact. 0.99. What is the ratio of the Net Disbursements (current US$) in Czech Republic in 2009 to that in 2012?
Keep it short and to the point. 1.59. What is the ratio of the Net Disbursements (current US$) of Poland in 2009 to that in 2012?
Your answer should be very brief. 1.12. What is the ratio of the Net Disbursements (current US$) of Slovak Republic in 2009 to that in 2012?
Your answer should be very brief. 0.83. What is the ratio of the Net Disbursements (current US$) of Czech Republic in 2009 to that in 2013?
Your answer should be very brief. 1.6. What is the ratio of the Net Disbursements (current US$) of Poland in 2009 to that in 2013?
Make the answer very short. 0.95. What is the ratio of the Net Disbursements (current US$) of Slovak Republic in 2009 to that in 2013?
Keep it short and to the point. 0.85. What is the ratio of the Net Disbursements (current US$) of Czech Republic in 2010 to that in 2011?
Offer a very short reply. 1.27. What is the ratio of the Net Disbursements (current US$) of Poland in 2010 to that in 2011?
Make the answer very short. 0.49. What is the ratio of the Net Disbursements (current US$) in Slovak Republic in 2010 to that in 2011?
Ensure brevity in your answer.  0.94. What is the ratio of the Net Disbursements (current US$) in Czech Republic in 2010 to that in 2012?
Offer a very short reply. 1.3. What is the ratio of the Net Disbursements (current US$) of Slovak Republic in 2010 to that in 2012?
Your response must be concise. 0.79. What is the ratio of the Net Disbursements (current US$) in Czech Republic in 2010 to that in 2013?
Offer a terse response. 1.31. What is the ratio of the Net Disbursements (current US$) of Poland in 2010 to that in 2013?
Provide a succinct answer. 0.84. What is the ratio of the Net Disbursements (current US$) of Slovak Republic in 2010 to that in 2013?
Ensure brevity in your answer.  0.81. What is the ratio of the Net Disbursements (current US$) in Czech Republic in 2011 to that in 2012?
Ensure brevity in your answer.  1.02. What is the ratio of the Net Disbursements (current US$) in Poland in 2011 to that in 2012?
Give a very brief answer. 2.02. What is the ratio of the Net Disbursements (current US$) in Slovak Republic in 2011 to that in 2012?
Offer a terse response. 0.84. What is the ratio of the Net Disbursements (current US$) of Czech Republic in 2011 to that in 2013?
Offer a very short reply. 1.03. What is the ratio of the Net Disbursements (current US$) in Poland in 2011 to that in 2013?
Provide a succinct answer. 1.71. What is the ratio of the Net Disbursements (current US$) in Slovak Republic in 2011 to that in 2013?
Make the answer very short. 0.86. What is the ratio of the Net Disbursements (current US$) in Czech Republic in 2012 to that in 2013?
Offer a very short reply. 1.01. What is the ratio of the Net Disbursements (current US$) in Poland in 2012 to that in 2013?
Your response must be concise. 0.85. What is the ratio of the Net Disbursements (current US$) of Slovak Republic in 2012 to that in 2013?
Make the answer very short. 1.02. What is the difference between the highest and the second highest Net Disbursements (current US$) of Czech Republic?
Your answer should be compact. 6.24e+06. What is the difference between the highest and the second highest Net Disbursements (current US$) in Poland?
Your answer should be compact. 1.67e+07. What is the difference between the highest and the lowest Net Disbursements (current US$) in Czech Republic?
Your answer should be very brief. 1.57e+07. What is the difference between the highest and the lowest Net Disbursements (current US$) of Poland?
Your response must be concise. 4.43e+07. What is the difference between the highest and the lowest Net Disbursements (current US$) of Slovak Republic?
Ensure brevity in your answer.  3.75e+06. 